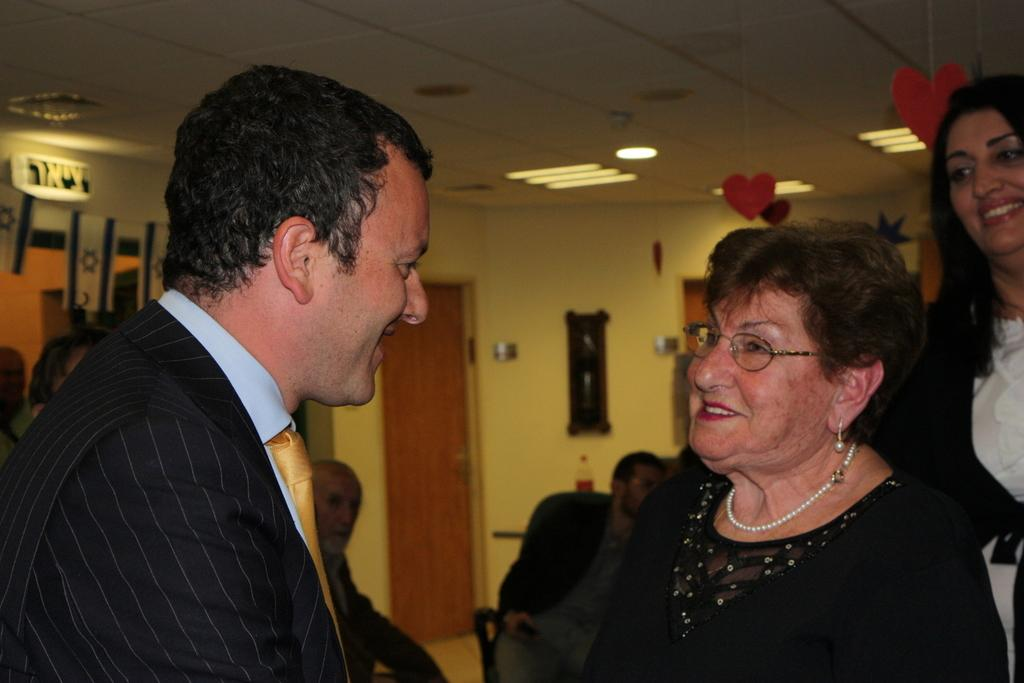Who or what is present in the image? There are people in the image. What are the people doing in the image? The people are talking to each other. What can be seen at the top of the image? There are lights visible at the top of the image. How many dogs are sitting on the committee in the image? There are no dogs or committee present in the image; it features people talking to each other. Where is the drawer located in the image? There is no drawer present in the image. 